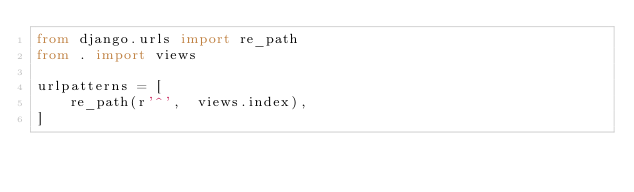Convert code to text. <code><loc_0><loc_0><loc_500><loc_500><_Python_>from django.urls import re_path
from . import views

urlpatterns = [
    re_path(r'^',  views.index),
]</code> 